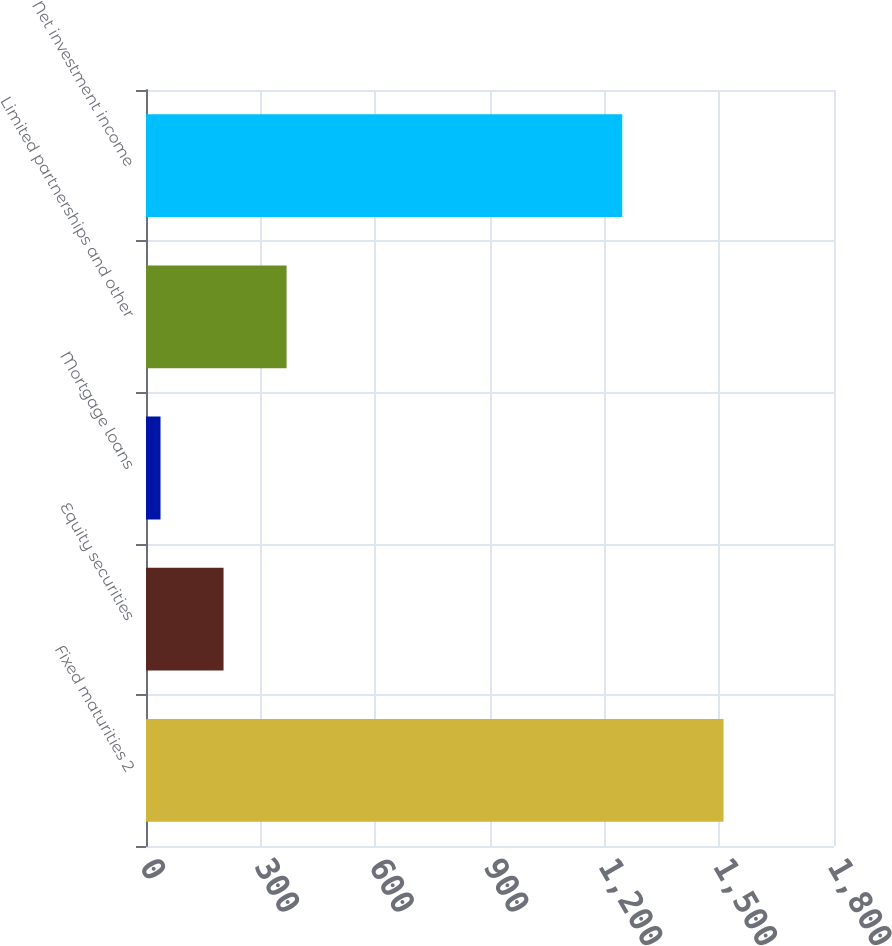Convert chart to OTSL. <chart><loc_0><loc_0><loc_500><loc_500><bar_chart><fcel>Fixed maturities 2<fcel>Equity securities<fcel>Mortgage loans<fcel>Limited partnerships and other<fcel>Net investment income<nl><fcel>1511<fcel>202.9<fcel>38<fcel>367.8<fcel>1246<nl></chart> 